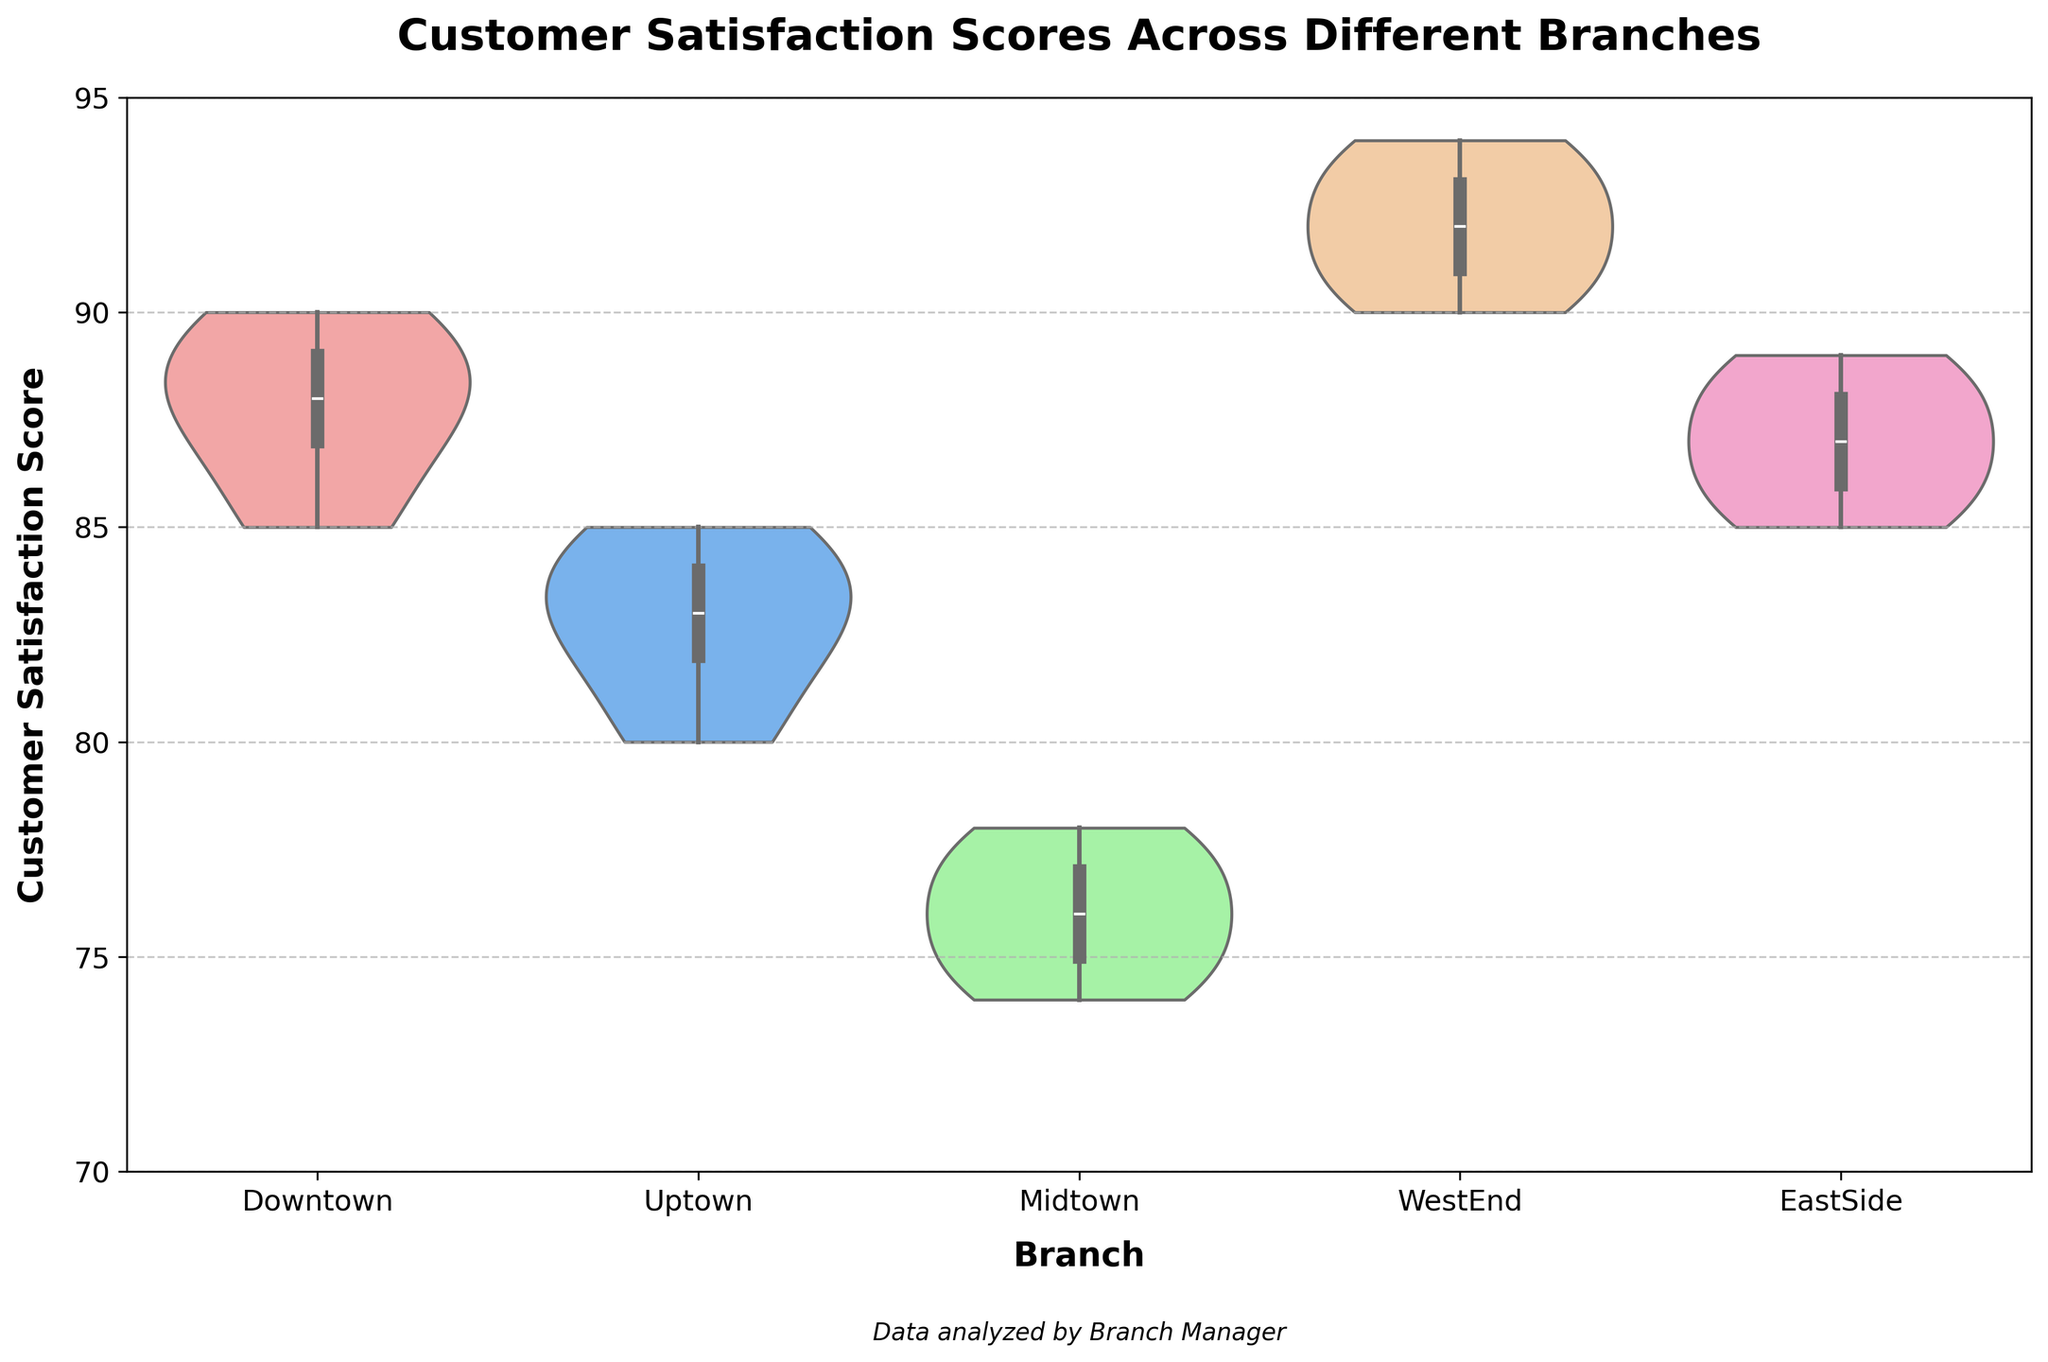What is the title of the figure? The title is displayed at the top of the figure, which summarizes the content of the chart. It states what the chart is about.
Answer: Customer Satisfaction Scores Across Different Branches How many branches are represented in the chart? The X-axis of the chart shows the distinct categories represented by different branches. You can count them to get the total number.
Answer: 5 Which branch has the widest distribution of customer satisfaction scores? The width of the violin plots indicates the distribution spread. Look for the branch with the broadest violin plot width.
Answer: Downtown What's the median customer satisfaction score for the WestEnd branch? The median value is shown as the thick center line inside each violin plot. Identify the line inside the WestEnd branch plot.
Answer: 92 Which branch has the highest maximum customer satisfaction score? The maximum value can be observed from the highest point of the plot's range. Identify which branch has the highest point.
Answer: WestEnd What is the range of customer satisfaction scores for the Midtown branch? The range is the difference between the maximum and minimum values shown by the ends of the violin plot for Midtown.
Answer: 74 to 78 Compare the levels of customer satisfaction between Downtown and EastSide branches. Which one has higher satisfaction? Examine the medians and distribution spreads of the Downtown and EastSide violin plots. Downtown's center line is higher, indicating a higher central tendency.
Answer: Downtown What is the interquartile range (IQR) of customer satisfaction scores for the Uptown branch? The IQR is the range between the first quartile (Q1) and the third quartile (Q3) values, represented by the thick box portion of the violin plot. Identify these limits and then subtract Q1 from Q3.
Answer: 80 to 85 Which branch shows the smallest variability in customer satisfaction scores? Variability is indicated by the height and spread of the violin plots. The plot with the narrowest spread and closest clustering of data points indicates the least variability.
Answer: WestEnd Compare the customer satisfaction score distribution between the branches with the lowest median score and the highest median score. What are they? Identify the branches by their median scores indicated on the violin plots. Midtown has the lowest median score while WestEnd has the highest.
Answer: Midtown and WestEnd 